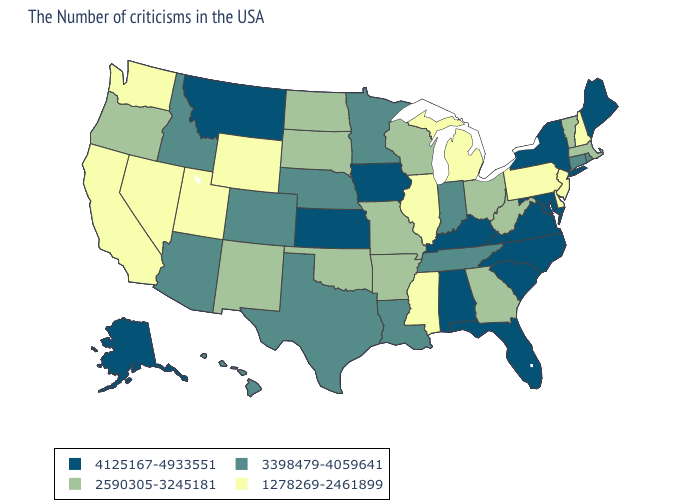Name the states that have a value in the range 4125167-4933551?
Short answer required. Maine, New York, Maryland, Virginia, North Carolina, South Carolina, Florida, Kentucky, Alabama, Iowa, Kansas, Montana, Alaska. Name the states that have a value in the range 2590305-3245181?
Be succinct. Massachusetts, Vermont, West Virginia, Ohio, Georgia, Wisconsin, Missouri, Arkansas, Oklahoma, South Dakota, North Dakota, New Mexico, Oregon. How many symbols are there in the legend?
Keep it brief. 4. What is the lowest value in states that border Mississippi?
Keep it brief. 2590305-3245181. Does Delaware have the lowest value in the South?
Concise answer only. Yes. What is the lowest value in states that border Louisiana?
Short answer required. 1278269-2461899. Does the map have missing data?
Concise answer only. No. Which states have the lowest value in the USA?
Give a very brief answer. New Hampshire, New Jersey, Delaware, Pennsylvania, Michigan, Illinois, Mississippi, Wyoming, Utah, Nevada, California, Washington. What is the value of Indiana?
Quick response, please. 3398479-4059641. Which states have the lowest value in the MidWest?
Keep it brief. Michigan, Illinois. Name the states that have a value in the range 1278269-2461899?
Quick response, please. New Hampshire, New Jersey, Delaware, Pennsylvania, Michigan, Illinois, Mississippi, Wyoming, Utah, Nevada, California, Washington. What is the value of Minnesota?
Concise answer only. 3398479-4059641. Does New Hampshire have the highest value in the Northeast?
Write a very short answer. No. What is the lowest value in the USA?
Short answer required. 1278269-2461899. Name the states that have a value in the range 1278269-2461899?
Short answer required. New Hampshire, New Jersey, Delaware, Pennsylvania, Michigan, Illinois, Mississippi, Wyoming, Utah, Nevada, California, Washington. 